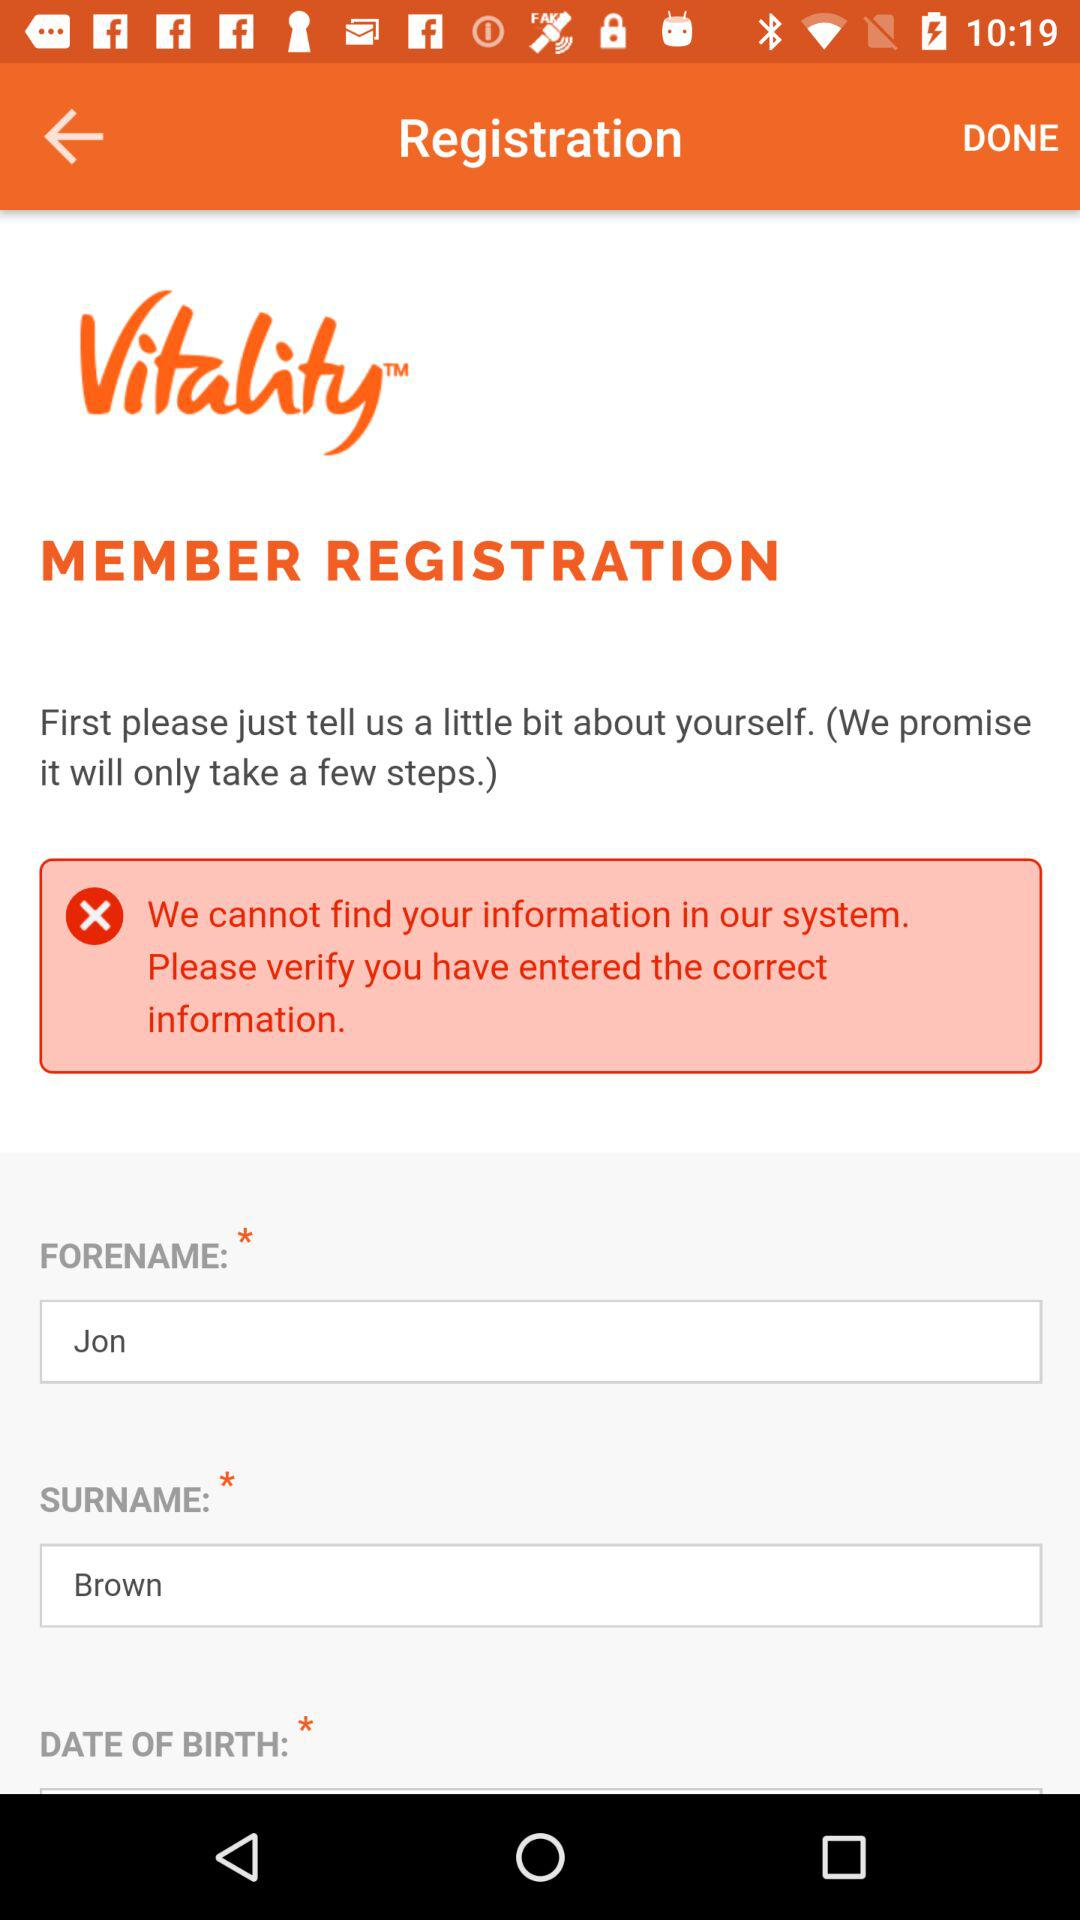What is the surname? The surname is Brown. 